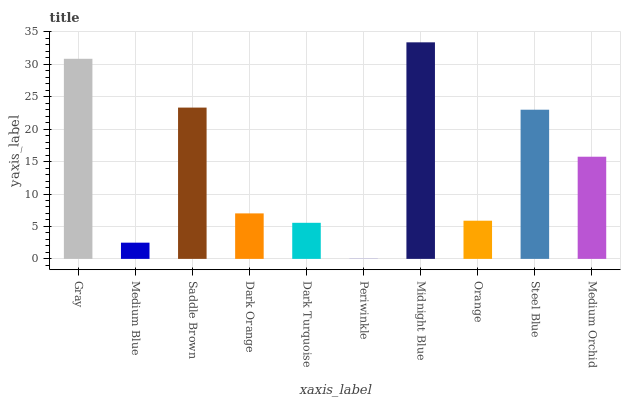Is Medium Blue the minimum?
Answer yes or no. No. Is Medium Blue the maximum?
Answer yes or no. No. Is Gray greater than Medium Blue?
Answer yes or no. Yes. Is Medium Blue less than Gray?
Answer yes or no. Yes. Is Medium Blue greater than Gray?
Answer yes or no. No. Is Gray less than Medium Blue?
Answer yes or no. No. Is Medium Orchid the high median?
Answer yes or no. Yes. Is Dark Orange the low median?
Answer yes or no. Yes. Is Orange the high median?
Answer yes or no. No. Is Dark Turquoise the low median?
Answer yes or no. No. 